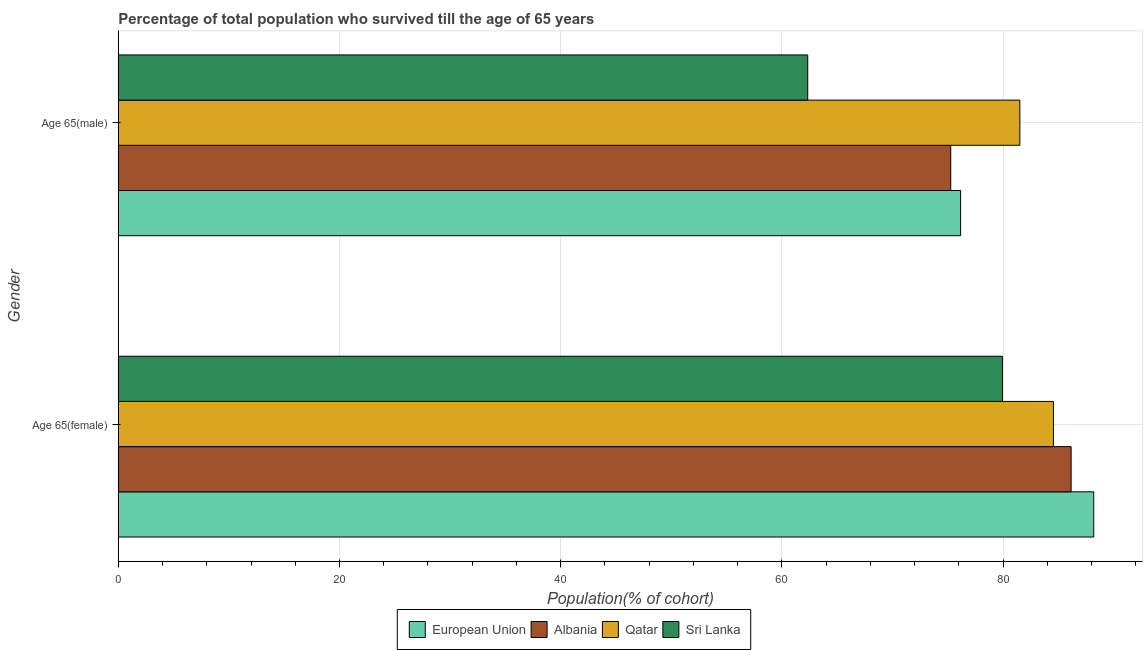How many different coloured bars are there?
Provide a succinct answer. 4. How many groups of bars are there?
Provide a succinct answer. 2. Are the number of bars per tick equal to the number of legend labels?
Keep it short and to the point. Yes. How many bars are there on the 1st tick from the top?
Your answer should be compact. 4. What is the label of the 2nd group of bars from the top?
Make the answer very short. Age 65(female). What is the percentage of male population who survived till age of 65 in Albania?
Keep it short and to the point. 75.26. Across all countries, what is the maximum percentage of female population who survived till age of 65?
Your response must be concise. 88.19. Across all countries, what is the minimum percentage of male population who survived till age of 65?
Provide a succinct answer. 62.34. In which country was the percentage of male population who survived till age of 65 maximum?
Keep it short and to the point. Qatar. In which country was the percentage of male population who survived till age of 65 minimum?
Offer a very short reply. Sri Lanka. What is the total percentage of female population who survived till age of 65 in the graph?
Your answer should be compact. 338.83. What is the difference between the percentage of female population who survived till age of 65 in European Union and that in Albania?
Provide a short and direct response. 2.04. What is the difference between the percentage of female population who survived till age of 65 in Albania and the percentage of male population who survived till age of 65 in Sri Lanka?
Provide a succinct answer. 23.81. What is the average percentage of female population who survived till age of 65 per country?
Offer a very short reply. 84.71. What is the difference between the percentage of male population who survived till age of 65 and percentage of female population who survived till age of 65 in Albania?
Your answer should be compact. -10.88. In how many countries, is the percentage of female population who survived till age of 65 greater than 20 %?
Provide a short and direct response. 4. What is the ratio of the percentage of female population who survived till age of 65 in European Union to that in Qatar?
Give a very brief answer. 1.04. What does the 4th bar from the top in Age 65(female) represents?
Offer a very short reply. European Union. What does the 3rd bar from the bottom in Age 65(female) represents?
Ensure brevity in your answer.  Qatar. How many bars are there?
Offer a terse response. 8. Are all the bars in the graph horizontal?
Give a very brief answer. Yes. How many countries are there in the graph?
Provide a succinct answer. 4. What is the difference between two consecutive major ticks on the X-axis?
Provide a succinct answer. 20. Are the values on the major ticks of X-axis written in scientific E-notation?
Offer a terse response. No. Does the graph contain any zero values?
Give a very brief answer. No. Where does the legend appear in the graph?
Give a very brief answer. Bottom center. How many legend labels are there?
Provide a short and direct response. 4. What is the title of the graph?
Make the answer very short. Percentage of total population who survived till the age of 65 years. Does "Bahamas" appear as one of the legend labels in the graph?
Your answer should be compact. No. What is the label or title of the X-axis?
Give a very brief answer. Population(% of cohort). What is the label or title of the Y-axis?
Make the answer very short. Gender. What is the Population(% of cohort) of European Union in Age 65(female)?
Make the answer very short. 88.19. What is the Population(% of cohort) of Albania in Age 65(female)?
Ensure brevity in your answer.  86.15. What is the Population(% of cohort) of Qatar in Age 65(female)?
Your response must be concise. 84.55. What is the Population(% of cohort) of Sri Lanka in Age 65(female)?
Give a very brief answer. 79.94. What is the Population(% of cohort) in European Union in Age 65(male)?
Give a very brief answer. 76.16. What is the Population(% of cohort) in Albania in Age 65(male)?
Your response must be concise. 75.26. What is the Population(% of cohort) in Qatar in Age 65(male)?
Your answer should be very brief. 81.51. What is the Population(% of cohort) of Sri Lanka in Age 65(male)?
Offer a very short reply. 62.34. Across all Gender, what is the maximum Population(% of cohort) in European Union?
Offer a terse response. 88.19. Across all Gender, what is the maximum Population(% of cohort) in Albania?
Your response must be concise. 86.15. Across all Gender, what is the maximum Population(% of cohort) of Qatar?
Provide a succinct answer. 84.55. Across all Gender, what is the maximum Population(% of cohort) of Sri Lanka?
Ensure brevity in your answer.  79.94. Across all Gender, what is the minimum Population(% of cohort) of European Union?
Give a very brief answer. 76.16. Across all Gender, what is the minimum Population(% of cohort) in Albania?
Provide a short and direct response. 75.26. Across all Gender, what is the minimum Population(% of cohort) of Qatar?
Ensure brevity in your answer.  81.51. Across all Gender, what is the minimum Population(% of cohort) of Sri Lanka?
Your answer should be compact. 62.34. What is the total Population(% of cohort) of European Union in the graph?
Ensure brevity in your answer.  164.35. What is the total Population(% of cohort) of Albania in the graph?
Your answer should be very brief. 161.41. What is the total Population(% of cohort) of Qatar in the graph?
Provide a short and direct response. 166.06. What is the total Population(% of cohort) in Sri Lanka in the graph?
Provide a short and direct response. 142.28. What is the difference between the Population(% of cohort) in European Union in Age 65(female) and that in Age 65(male)?
Your answer should be very brief. 12.04. What is the difference between the Population(% of cohort) of Albania in Age 65(female) and that in Age 65(male)?
Your answer should be compact. 10.88. What is the difference between the Population(% of cohort) of Qatar in Age 65(female) and that in Age 65(male)?
Offer a very short reply. 3.04. What is the difference between the Population(% of cohort) of Sri Lanka in Age 65(female) and that in Age 65(male)?
Offer a very short reply. 17.6. What is the difference between the Population(% of cohort) of European Union in Age 65(female) and the Population(% of cohort) of Albania in Age 65(male)?
Make the answer very short. 12.93. What is the difference between the Population(% of cohort) of European Union in Age 65(female) and the Population(% of cohort) of Qatar in Age 65(male)?
Keep it short and to the point. 6.68. What is the difference between the Population(% of cohort) of European Union in Age 65(female) and the Population(% of cohort) of Sri Lanka in Age 65(male)?
Offer a very short reply. 25.86. What is the difference between the Population(% of cohort) in Albania in Age 65(female) and the Population(% of cohort) in Qatar in Age 65(male)?
Offer a very short reply. 4.64. What is the difference between the Population(% of cohort) of Albania in Age 65(female) and the Population(% of cohort) of Sri Lanka in Age 65(male)?
Make the answer very short. 23.81. What is the difference between the Population(% of cohort) in Qatar in Age 65(female) and the Population(% of cohort) in Sri Lanka in Age 65(male)?
Make the answer very short. 22.21. What is the average Population(% of cohort) of European Union per Gender?
Your answer should be compact. 82.17. What is the average Population(% of cohort) of Albania per Gender?
Make the answer very short. 80.71. What is the average Population(% of cohort) of Qatar per Gender?
Make the answer very short. 83.03. What is the average Population(% of cohort) in Sri Lanka per Gender?
Offer a very short reply. 71.14. What is the difference between the Population(% of cohort) in European Union and Population(% of cohort) in Albania in Age 65(female)?
Ensure brevity in your answer.  2.04. What is the difference between the Population(% of cohort) of European Union and Population(% of cohort) of Qatar in Age 65(female)?
Offer a very short reply. 3.64. What is the difference between the Population(% of cohort) of European Union and Population(% of cohort) of Sri Lanka in Age 65(female)?
Offer a very short reply. 8.25. What is the difference between the Population(% of cohort) of Albania and Population(% of cohort) of Qatar in Age 65(female)?
Provide a short and direct response. 1.6. What is the difference between the Population(% of cohort) of Albania and Population(% of cohort) of Sri Lanka in Age 65(female)?
Give a very brief answer. 6.21. What is the difference between the Population(% of cohort) in Qatar and Population(% of cohort) in Sri Lanka in Age 65(female)?
Give a very brief answer. 4.61. What is the difference between the Population(% of cohort) of European Union and Population(% of cohort) of Albania in Age 65(male)?
Offer a terse response. 0.89. What is the difference between the Population(% of cohort) in European Union and Population(% of cohort) in Qatar in Age 65(male)?
Provide a short and direct response. -5.36. What is the difference between the Population(% of cohort) in European Union and Population(% of cohort) in Sri Lanka in Age 65(male)?
Offer a terse response. 13.82. What is the difference between the Population(% of cohort) of Albania and Population(% of cohort) of Qatar in Age 65(male)?
Offer a very short reply. -6.25. What is the difference between the Population(% of cohort) in Albania and Population(% of cohort) in Sri Lanka in Age 65(male)?
Provide a short and direct response. 12.93. What is the difference between the Population(% of cohort) of Qatar and Population(% of cohort) of Sri Lanka in Age 65(male)?
Your answer should be very brief. 19.18. What is the ratio of the Population(% of cohort) in European Union in Age 65(female) to that in Age 65(male)?
Keep it short and to the point. 1.16. What is the ratio of the Population(% of cohort) of Albania in Age 65(female) to that in Age 65(male)?
Keep it short and to the point. 1.14. What is the ratio of the Population(% of cohort) of Qatar in Age 65(female) to that in Age 65(male)?
Your answer should be very brief. 1.04. What is the ratio of the Population(% of cohort) of Sri Lanka in Age 65(female) to that in Age 65(male)?
Ensure brevity in your answer.  1.28. What is the difference between the highest and the second highest Population(% of cohort) in European Union?
Your response must be concise. 12.04. What is the difference between the highest and the second highest Population(% of cohort) of Albania?
Keep it short and to the point. 10.88. What is the difference between the highest and the second highest Population(% of cohort) in Qatar?
Provide a short and direct response. 3.04. What is the difference between the highest and the second highest Population(% of cohort) in Sri Lanka?
Keep it short and to the point. 17.6. What is the difference between the highest and the lowest Population(% of cohort) in European Union?
Your answer should be very brief. 12.04. What is the difference between the highest and the lowest Population(% of cohort) in Albania?
Provide a short and direct response. 10.88. What is the difference between the highest and the lowest Population(% of cohort) in Qatar?
Keep it short and to the point. 3.04. What is the difference between the highest and the lowest Population(% of cohort) in Sri Lanka?
Give a very brief answer. 17.6. 